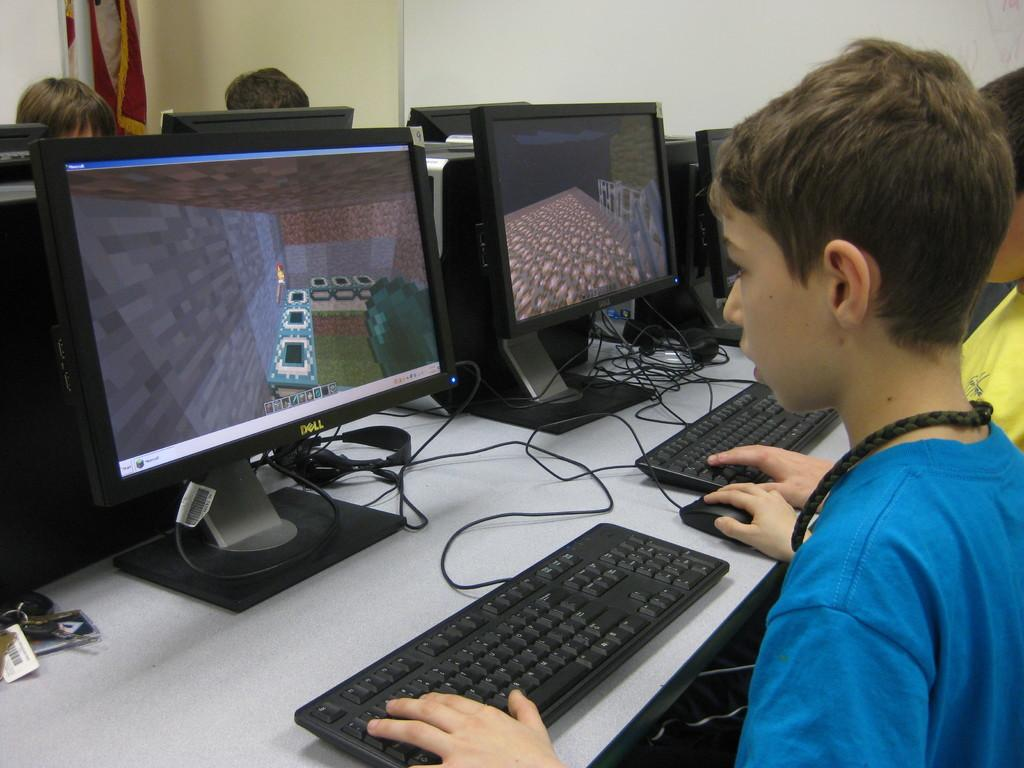<image>
Create a compact narrative representing the image presented. Children sit at computers, a boy in a blue t-shirt working on a Dell. 